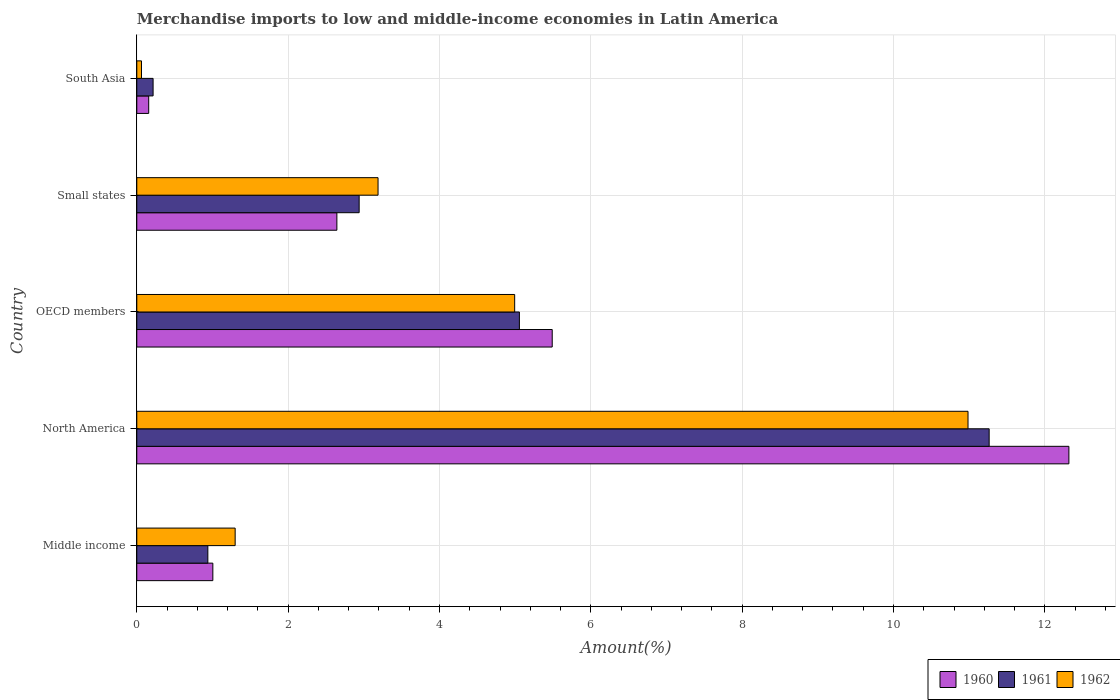How many different coloured bars are there?
Your answer should be very brief. 3. Are the number of bars on each tick of the Y-axis equal?
Make the answer very short. Yes. How many bars are there on the 3rd tick from the top?
Keep it short and to the point. 3. What is the label of the 5th group of bars from the top?
Offer a very short reply. Middle income. In how many cases, is the number of bars for a given country not equal to the number of legend labels?
Offer a very short reply. 0. What is the percentage of amount earned from merchandise imports in 1960 in OECD members?
Keep it short and to the point. 5.49. Across all countries, what is the maximum percentage of amount earned from merchandise imports in 1961?
Ensure brevity in your answer.  11.26. Across all countries, what is the minimum percentage of amount earned from merchandise imports in 1962?
Give a very brief answer. 0.06. In which country was the percentage of amount earned from merchandise imports in 1962 maximum?
Your answer should be compact. North America. What is the total percentage of amount earned from merchandise imports in 1960 in the graph?
Your response must be concise. 21.62. What is the difference between the percentage of amount earned from merchandise imports in 1960 in Middle income and that in OECD members?
Give a very brief answer. -4.49. What is the difference between the percentage of amount earned from merchandise imports in 1961 in North America and the percentage of amount earned from merchandise imports in 1962 in South Asia?
Keep it short and to the point. 11.2. What is the average percentage of amount earned from merchandise imports in 1960 per country?
Your answer should be compact. 4.32. What is the difference between the percentage of amount earned from merchandise imports in 1962 and percentage of amount earned from merchandise imports in 1961 in Small states?
Offer a terse response. 0.25. In how many countries, is the percentage of amount earned from merchandise imports in 1960 greater than 12 %?
Give a very brief answer. 1. What is the ratio of the percentage of amount earned from merchandise imports in 1961 in Middle income to that in Small states?
Ensure brevity in your answer.  0.32. Is the percentage of amount earned from merchandise imports in 1960 in Middle income less than that in North America?
Keep it short and to the point. Yes. What is the difference between the highest and the second highest percentage of amount earned from merchandise imports in 1962?
Your answer should be very brief. 5.99. What is the difference between the highest and the lowest percentage of amount earned from merchandise imports in 1960?
Make the answer very short. 12.16. What does the 1st bar from the top in North America represents?
Your response must be concise. 1962. What does the 2nd bar from the bottom in South Asia represents?
Give a very brief answer. 1961. How many bars are there?
Offer a terse response. 15. How many countries are there in the graph?
Keep it short and to the point. 5. What is the difference between two consecutive major ticks on the X-axis?
Your answer should be very brief. 2. How many legend labels are there?
Your answer should be very brief. 3. What is the title of the graph?
Provide a succinct answer. Merchandise imports to low and middle-income economies in Latin America. What is the label or title of the X-axis?
Provide a succinct answer. Amount(%). What is the Amount(%) of 1960 in Middle income?
Keep it short and to the point. 1.01. What is the Amount(%) of 1961 in Middle income?
Ensure brevity in your answer.  0.94. What is the Amount(%) of 1962 in Middle income?
Provide a succinct answer. 1.3. What is the Amount(%) of 1960 in North America?
Provide a succinct answer. 12.32. What is the Amount(%) in 1961 in North America?
Your answer should be very brief. 11.26. What is the Amount(%) in 1962 in North America?
Give a very brief answer. 10.99. What is the Amount(%) of 1960 in OECD members?
Give a very brief answer. 5.49. What is the Amount(%) in 1961 in OECD members?
Provide a short and direct response. 5.06. What is the Amount(%) in 1962 in OECD members?
Make the answer very short. 4.99. What is the Amount(%) of 1960 in Small states?
Make the answer very short. 2.64. What is the Amount(%) of 1961 in Small states?
Make the answer very short. 2.94. What is the Amount(%) of 1962 in Small states?
Offer a very short reply. 3.19. What is the Amount(%) in 1960 in South Asia?
Provide a short and direct response. 0.16. What is the Amount(%) in 1961 in South Asia?
Provide a short and direct response. 0.22. What is the Amount(%) of 1962 in South Asia?
Give a very brief answer. 0.06. Across all countries, what is the maximum Amount(%) in 1960?
Your answer should be very brief. 12.32. Across all countries, what is the maximum Amount(%) of 1961?
Your answer should be very brief. 11.26. Across all countries, what is the maximum Amount(%) of 1962?
Provide a succinct answer. 10.99. Across all countries, what is the minimum Amount(%) in 1960?
Give a very brief answer. 0.16. Across all countries, what is the minimum Amount(%) of 1961?
Ensure brevity in your answer.  0.22. Across all countries, what is the minimum Amount(%) of 1962?
Provide a short and direct response. 0.06. What is the total Amount(%) in 1960 in the graph?
Keep it short and to the point. 21.62. What is the total Amount(%) in 1961 in the graph?
Offer a very short reply. 20.41. What is the total Amount(%) of 1962 in the graph?
Provide a short and direct response. 20.53. What is the difference between the Amount(%) of 1960 in Middle income and that in North America?
Your answer should be very brief. -11.31. What is the difference between the Amount(%) in 1961 in Middle income and that in North America?
Offer a terse response. -10.33. What is the difference between the Amount(%) of 1962 in Middle income and that in North America?
Provide a succinct answer. -9.69. What is the difference between the Amount(%) in 1960 in Middle income and that in OECD members?
Your response must be concise. -4.49. What is the difference between the Amount(%) of 1961 in Middle income and that in OECD members?
Offer a very short reply. -4.12. What is the difference between the Amount(%) in 1962 in Middle income and that in OECD members?
Your answer should be compact. -3.69. What is the difference between the Amount(%) in 1960 in Middle income and that in Small states?
Your response must be concise. -1.64. What is the difference between the Amount(%) of 1961 in Middle income and that in Small states?
Offer a terse response. -2. What is the difference between the Amount(%) of 1962 in Middle income and that in Small states?
Provide a short and direct response. -1.89. What is the difference between the Amount(%) of 1960 in Middle income and that in South Asia?
Your answer should be compact. 0.85. What is the difference between the Amount(%) in 1961 in Middle income and that in South Asia?
Offer a very short reply. 0.72. What is the difference between the Amount(%) of 1962 in Middle income and that in South Asia?
Ensure brevity in your answer.  1.24. What is the difference between the Amount(%) of 1960 in North America and that in OECD members?
Your response must be concise. 6.83. What is the difference between the Amount(%) in 1961 in North America and that in OECD members?
Offer a terse response. 6.21. What is the difference between the Amount(%) of 1962 in North America and that in OECD members?
Keep it short and to the point. 5.99. What is the difference between the Amount(%) in 1960 in North America and that in Small states?
Your response must be concise. 9.67. What is the difference between the Amount(%) in 1961 in North America and that in Small states?
Keep it short and to the point. 8.33. What is the difference between the Amount(%) of 1962 in North America and that in Small states?
Your answer should be compact. 7.8. What is the difference between the Amount(%) in 1960 in North America and that in South Asia?
Offer a terse response. 12.16. What is the difference between the Amount(%) of 1961 in North America and that in South Asia?
Make the answer very short. 11.05. What is the difference between the Amount(%) in 1962 in North America and that in South Asia?
Provide a short and direct response. 10.92. What is the difference between the Amount(%) of 1960 in OECD members and that in Small states?
Provide a succinct answer. 2.85. What is the difference between the Amount(%) in 1961 in OECD members and that in Small states?
Your response must be concise. 2.12. What is the difference between the Amount(%) in 1962 in OECD members and that in Small states?
Offer a terse response. 1.81. What is the difference between the Amount(%) in 1960 in OECD members and that in South Asia?
Keep it short and to the point. 5.33. What is the difference between the Amount(%) in 1961 in OECD members and that in South Asia?
Your response must be concise. 4.84. What is the difference between the Amount(%) in 1962 in OECD members and that in South Asia?
Ensure brevity in your answer.  4.93. What is the difference between the Amount(%) in 1960 in Small states and that in South Asia?
Your answer should be very brief. 2.49. What is the difference between the Amount(%) in 1961 in Small states and that in South Asia?
Give a very brief answer. 2.72. What is the difference between the Amount(%) in 1962 in Small states and that in South Asia?
Ensure brevity in your answer.  3.13. What is the difference between the Amount(%) of 1960 in Middle income and the Amount(%) of 1961 in North America?
Offer a terse response. -10.26. What is the difference between the Amount(%) in 1960 in Middle income and the Amount(%) in 1962 in North America?
Your answer should be compact. -9.98. What is the difference between the Amount(%) of 1961 in Middle income and the Amount(%) of 1962 in North America?
Offer a terse response. -10.05. What is the difference between the Amount(%) of 1960 in Middle income and the Amount(%) of 1961 in OECD members?
Offer a terse response. -4.05. What is the difference between the Amount(%) of 1960 in Middle income and the Amount(%) of 1962 in OECD members?
Provide a short and direct response. -3.99. What is the difference between the Amount(%) of 1961 in Middle income and the Amount(%) of 1962 in OECD members?
Keep it short and to the point. -4.05. What is the difference between the Amount(%) in 1960 in Middle income and the Amount(%) in 1961 in Small states?
Make the answer very short. -1.93. What is the difference between the Amount(%) of 1960 in Middle income and the Amount(%) of 1962 in Small states?
Provide a short and direct response. -2.18. What is the difference between the Amount(%) in 1961 in Middle income and the Amount(%) in 1962 in Small states?
Your response must be concise. -2.25. What is the difference between the Amount(%) in 1960 in Middle income and the Amount(%) in 1961 in South Asia?
Offer a terse response. 0.79. What is the difference between the Amount(%) in 1960 in Middle income and the Amount(%) in 1962 in South Asia?
Offer a very short reply. 0.94. What is the difference between the Amount(%) in 1961 in Middle income and the Amount(%) in 1962 in South Asia?
Keep it short and to the point. 0.88. What is the difference between the Amount(%) of 1960 in North America and the Amount(%) of 1961 in OECD members?
Make the answer very short. 7.26. What is the difference between the Amount(%) of 1960 in North America and the Amount(%) of 1962 in OECD members?
Your response must be concise. 7.32. What is the difference between the Amount(%) in 1961 in North America and the Amount(%) in 1962 in OECD members?
Give a very brief answer. 6.27. What is the difference between the Amount(%) in 1960 in North America and the Amount(%) in 1961 in Small states?
Your answer should be compact. 9.38. What is the difference between the Amount(%) in 1960 in North America and the Amount(%) in 1962 in Small states?
Your answer should be compact. 9.13. What is the difference between the Amount(%) of 1961 in North America and the Amount(%) of 1962 in Small states?
Your answer should be very brief. 8.08. What is the difference between the Amount(%) of 1960 in North America and the Amount(%) of 1961 in South Asia?
Ensure brevity in your answer.  12.1. What is the difference between the Amount(%) of 1960 in North America and the Amount(%) of 1962 in South Asia?
Make the answer very short. 12.26. What is the difference between the Amount(%) in 1961 in North America and the Amount(%) in 1962 in South Asia?
Provide a succinct answer. 11.2. What is the difference between the Amount(%) in 1960 in OECD members and the Amount(%) in 1961 in Small states?
Give a very brief answer. 2.55. What is the difference between the Amount(%) of 1960 in OECD members and the Amount(%) of 1962 in Small states?
Your answer should be very brief. 2.3. What is the difference between the Amount(%) of 1961 in OECD members and the Amount(%) of 1962 in Small states?
Ensure brevity in your answer.  1.87. What is the difference between the Amount(%) of 1960 in OECD members and the Amount(%) of 1961 in South Asia?
Your answer should be very brief. 5.27. What is the difference between the Amount(%) in 1960 in OECD members and the Amount(%) in 1962 in South Asia?
Make the answer very short. 5.43. What is the difference between the Amount(%) of 1961 in OECD members and the Amount(%) of 1962 in South Asia?
Make the answer very short. 4.99. What is the difference between the Amount(%) of 1960 in Small states and the Amount(%) of 1961 in South Asia?
Make the answer very short. 2.43. What is the difference between the Amount(%) in 1960 in Small states and the Amount(%) in 1962 in South Asia?
Provide a short and direct response. 2.58. What is the difference between the Amount(%) in 1961 in Small states and the Amount(%) in 1962 in South Asia?
Your answer should be compact. 2.88. What is the average Amount(%) in 1960 per country?
Your answer should be compact. 4.32. What is the average Amount(%) of 1961 per country?
Ensure brevity in your answer.  4.08. What is the average Amount(%) of 1962 per country?
Ensure brevity in your answer.  4.11. What is the difference between the Amount(%) of 1960 and Amount(%) of 1961 in Middle income?
Offer a very short reply. 0.07. What is the difference between the Amount(%) in 1960 and Amount(%) in 1962 in Middle income?
Give a very brief answer. -0.29. What is the difference between the Amount(%) of 1961 and Amount(%) of 1962 in Middle income?
Give a very brief answer. -0.36. What is the difference between the Amount(%) in 1960 and Amount(%) in 1961 in North America?
Give a very brief answer. 1.05. What is the difference between the Amount(%) of 1960 and Amount(%) of 1962 in North America?
Offer a very short reply. 1.33. What is the difference between the Amount(%) in 1961 and Amount(%) in 1962 in North America?
Your answer should be compact. 0.28. What is the difference between the Amount(%) of 1960 and Amount(%) of 1961 in OECD members?
Offer a terse response. 0.43. What is the difference between the Amount(%) of 1960 and Amount(%) of 1962 in OECD members?
Your answer should be compact. 0.5. What is the difference between the Amount(%) of 1961 and Amount(%) of 1962 in OECD members?
Provide a succinct answer. 0.06. What is the difference between the Amount(%) in 1960 and Amount(%) in 1961 in Small states?
Your answer should be compact. -0.29. What is the difference between the Amount(%) of 1960 and Amount(%) of 1962 in Small states?
Ensure brevity in your answer.  -0.54. What is the difference between the Amount(%) in 1961 and Amount(%) in 1962 in Small states?
Give a very brief answer. -0.25. What is the difference between the Amount(%) in 1960 and Amount(%) in 1961 in South Asia?
Your answer should be compact. -0.06. What is the difference between the Amount(%) of 1960 and Amount(%) of 1962 in South Asia?
Your answer should be compact. 0.1. What is the difference between the Amount(%) of 1961 and Amount(%) of 1962 in South Asia?
Give a very brief answer. 0.15. What is the ratio of the Amount(%) of 1960 in Middle income to that in North America?
Offer a very short reply. 0.08. What is the ratio of the Amount(%) in 1961 in Middle income to that in North America?
Keep it short and to the point. 0.08. What is the ratio of the Amount(%) of 1962 in Middle income to that in North America?
Your answer should be compact. 0.12. What is the ratio of the Amount(%) in 1960 in Middle income to that in OECD members?
Ensure brevity in your answer.  0.18. What is the ratio of the Amount(%) of 1961 in Middle income to that in OECD members?
Provide a short and direct response. 0.19. What is the ratio of the Amount(%) of 1962 in Middle income to that in OECD members?
Keep it short and to the point. 0.26. What is the ratio of the Amount(%) of 1960 in Middle income to that in Small states?
Ensure brevity in your answer.  0.38. What is the ratio of the Amount(%) in 1961 in Middle income to that in Small states?
Your answer should be compact. 0.32. What is the ratio of the Amount(%) of 1962 in Middle income to that in Small states?
Offer a terse response. 0.41. What is the ratio of the Amount(%) of 1960 in Middle income to that in South Asia?
Give a very brief answer. 6.38. What is the ratio of the Amount(%) in 1961 in Middle income to that in South Asia?
Give a very brief answer. 4.36. What is the ratio of the Amount(%) of 1962 in Middle income to that in South Asia?
Provide a short and direct response. 20.96. What is the ratio of the Amount(%) in 1960 in North America to that in OECD members?
Your response must be concise. 2.24. What is the ratio of the Amount(%) in 1961 in North America to that in OECD members?
Make the answer very short. 2.23. What is the ratio of the Amount(%) of 1962 in North America to that in OECD members?
Your answer should be very brief. 2.2. What is the ratio of the Amount(%) in 1960 in North America to that in Small states?
Make the answer very short. 4.66. What is the ratio of the Amount(%) in 1961 in North America to that in Small states?
Provide a succinct answer. 3.83. What is the ratio of the Amount(%) in 1962 in North America to that in Small states?
Make the answer very short. 3.45. What is the ratio of the Amount(%) in 1960 in North America to that in South Asia?
Provide a succinct answer. 78.22. What is the ratio of the Amount(%) of 1961 in North America to that in South Asia?
Provide a succinct answer. 52.26. What is the ratio of the Amount(%) in 1962 in North America to that in South Asia?
Keep it short and to the point. 177.15. What is the ratio of the Amount(%) of 1960 in OECD members to that in Small states?
Your answer should be very brief. 2.08. What is the ratio of the Amount(%) in 1961 in OECD members to that in Small states?
Make the answer very short. 1.72. What is the ratio of the Amount(%) of 1962 in OECD members to that in Small states?
Your answer should be compact. 1.57. What is the ratio of the Amount(%) in 1960 in OECD members to that in South Asia?
Ensure brevity in your answer.  34.86. What is the ratio of the Amount(%) in 1961 in OECD members to that in South Asia?
Offer a very short reply. 23.46. What is the ratio of the Amount(%) in 1962 in OECD members to that in South Asia?
Offer a very short reply. 80.53. What is the ratio of the Amount(%) in 1960 in Small states to that in South Asia?
Your answer should be compact. 16.79. What is the ratio of the Amount(%) of 1961 in Small states to that in South Asia?
Offer a terse response. 13.63. What is the ratio of the Amount(%) of 1962 in Small states to that in South Asia?
Your response must be concise. 51.42. What is the difference between the highest and the second highest Amount(%) of 1960?
Keep it short and to the point. 6.83. What is the difference between the highest and the second highest Amount(%) of 1961?
Provide a short and direct response. 6.21. What is the difference between the highest and the second highest Amount(%) of 1962?
Your response must be concise. 5.99. What is the difference between the highest and the lowest Amount(%) of 1960?
Keep it short and to the point. 12.16. What is the difference between the highest and the lowest Amount(%) in 1961?
Your answer should be compact. 11.05. What is the difference between the highest and the lowest Amount(%) in 1962?
Your answer should be compact. 10.92. 